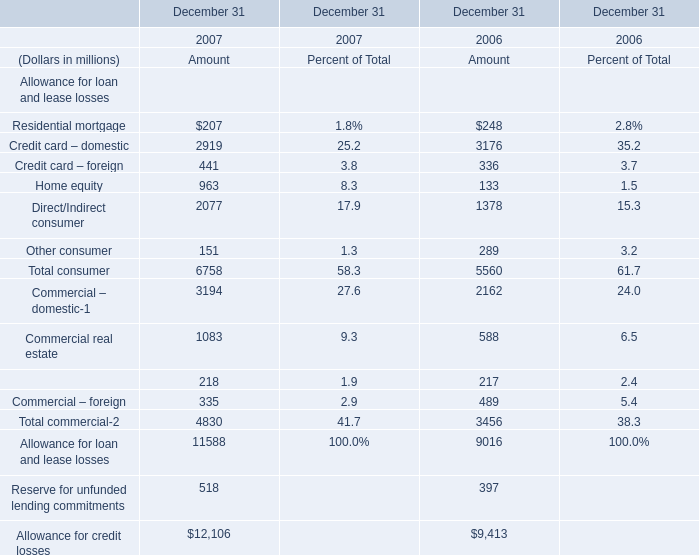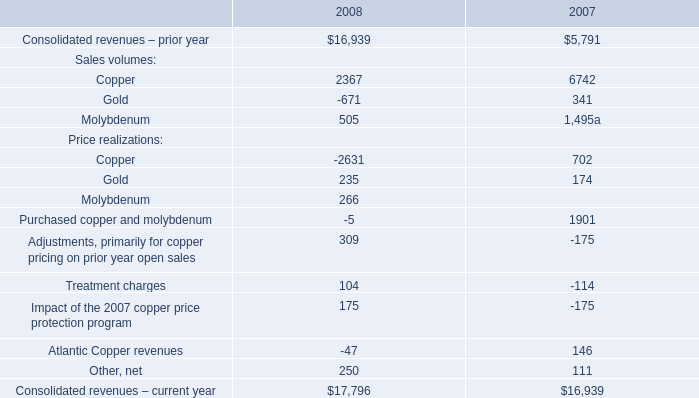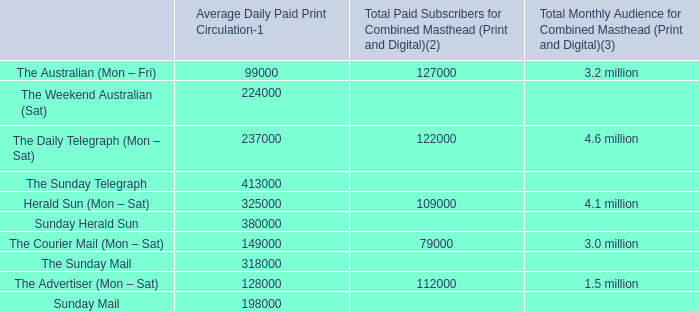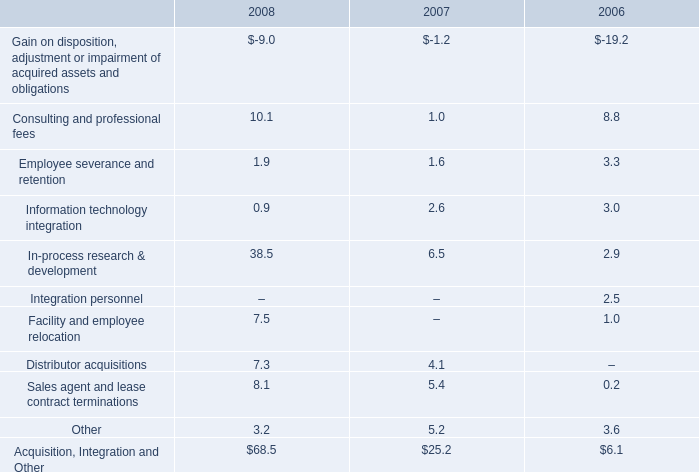what is the sale of the former centerpulse austin land and facilities as a percentage of the gain on disposition adjustment or impairment of acquired assets and obligations in 2006? 
Computations: (5.1 / 19.2)
Answer: 0.26562. 